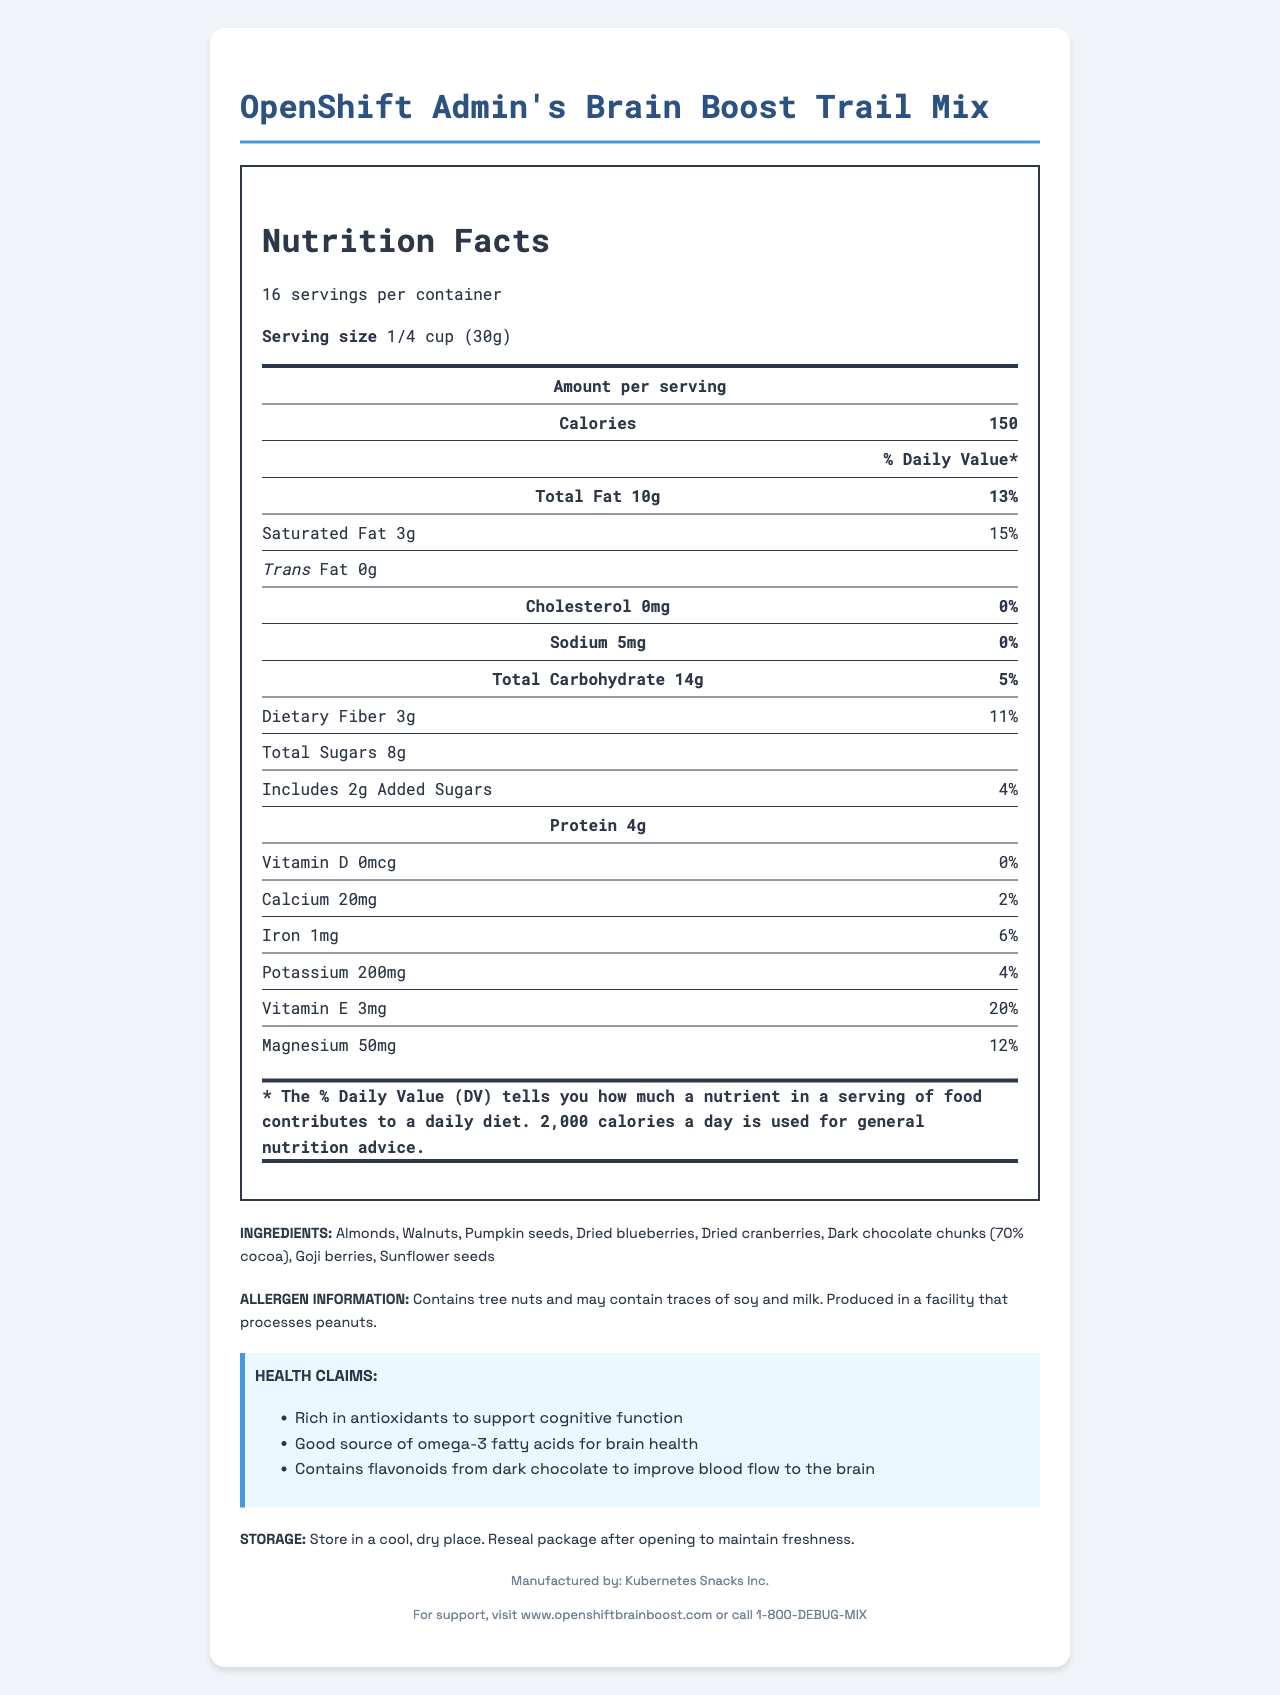What is the serving size of the OpenShift Admin's Brain Boost Trail Mix? The serving size is clearly stated at the beginning of the Nutrition Facts section.
Answer: 1/4 cup (30g) How many servings are in each container? This information is listed right after the product name in the Nutrition Facts section.
Answer: 16 What is the calorie count per serving? The calorie count per serving is displayed prominently at the top of the nutrition facts.
Answer: 150 How much saturated fat is in one serving? This information is found under the Total Fat section of the Nutrition Facts.
Answer: 3g Which mineral in the trail mix contributes 12% of the daily value? Under the Nutrition Facts, Magnesium shows an amount of 50mg, which is 12% of the daily value.
Answer: Magnesium Does the product contain any trans fat? The Nutrition Facts section clearly states that the amount of trans fat is 0g.
Answer: No Which ingredient is not in the trail mix? A. Sunflower seeds B. Almonds C. Peanuts D. Dried blueberries Peanuts are not listed in the ingredients section.
Answer: C. Peanuts Which health claim is made about the dark chocolate in the trail mix? A. Rich in Vitamin D B. Contains flavonoids to improve blood flow to the brain C. Good source of protein This health claim is listed in the Health Claims section.
Answer: B. Contains flavonoids to improve blood flow to the brain Is the trail mix gluten-free? The document does not provide any information about whether the trail mix is gluten-free or not.
Answer: Cannot be determined What is the sodium content per serving of this trail mix? The actual sodium content is listed in the Nutrition Facts section.
Answer: 5mg Is the trail mix suitable for someone with a tree nut allergy? The allergen information states that the product contains tree nuts.
Answer: No How much protein is in one serving? The amount of protein per serving is listed in the Nutrition Facts section.
Answer: 4g What should you do to maintain the freshness of the trail mix after opening it? This information is provided in the Storage Instructions section.
Answer: Reseal the package after opening Manufactured by which company? The manufacturer is listed in the footer of the document.
Answer: Kubernetes Snacks Inc. What is the amount of potassium per serving in the trail mix? This information is found under the Nutrition Facts section.
Answer: 200mg Summarize the main points of the nutrition label for OpenShift Admin's Brain Boost Trail Mix. The document provides comprehensive information about the nutritional content, ingredients, allergen warnings, and health benefits of the trail mix. It also includes storage instructions and manufacturer details.
Answer: The nutrition label for OpenShift Admin's Brain Boost Trail Mix details the serving size of 1/4 cup (30g) and indicates that there are 16 servings per container. Each serving contains 150 calories, and it details the amounts and daily values of various nutrients, including 10g of total fat, 14g of carbohydrates, and 4g of protein. The ingredient list includes various nuts, seeds, dried fruits, and dark chocolate. The label also provides allergen information and health claims associated with cognitive functions and brain health. 